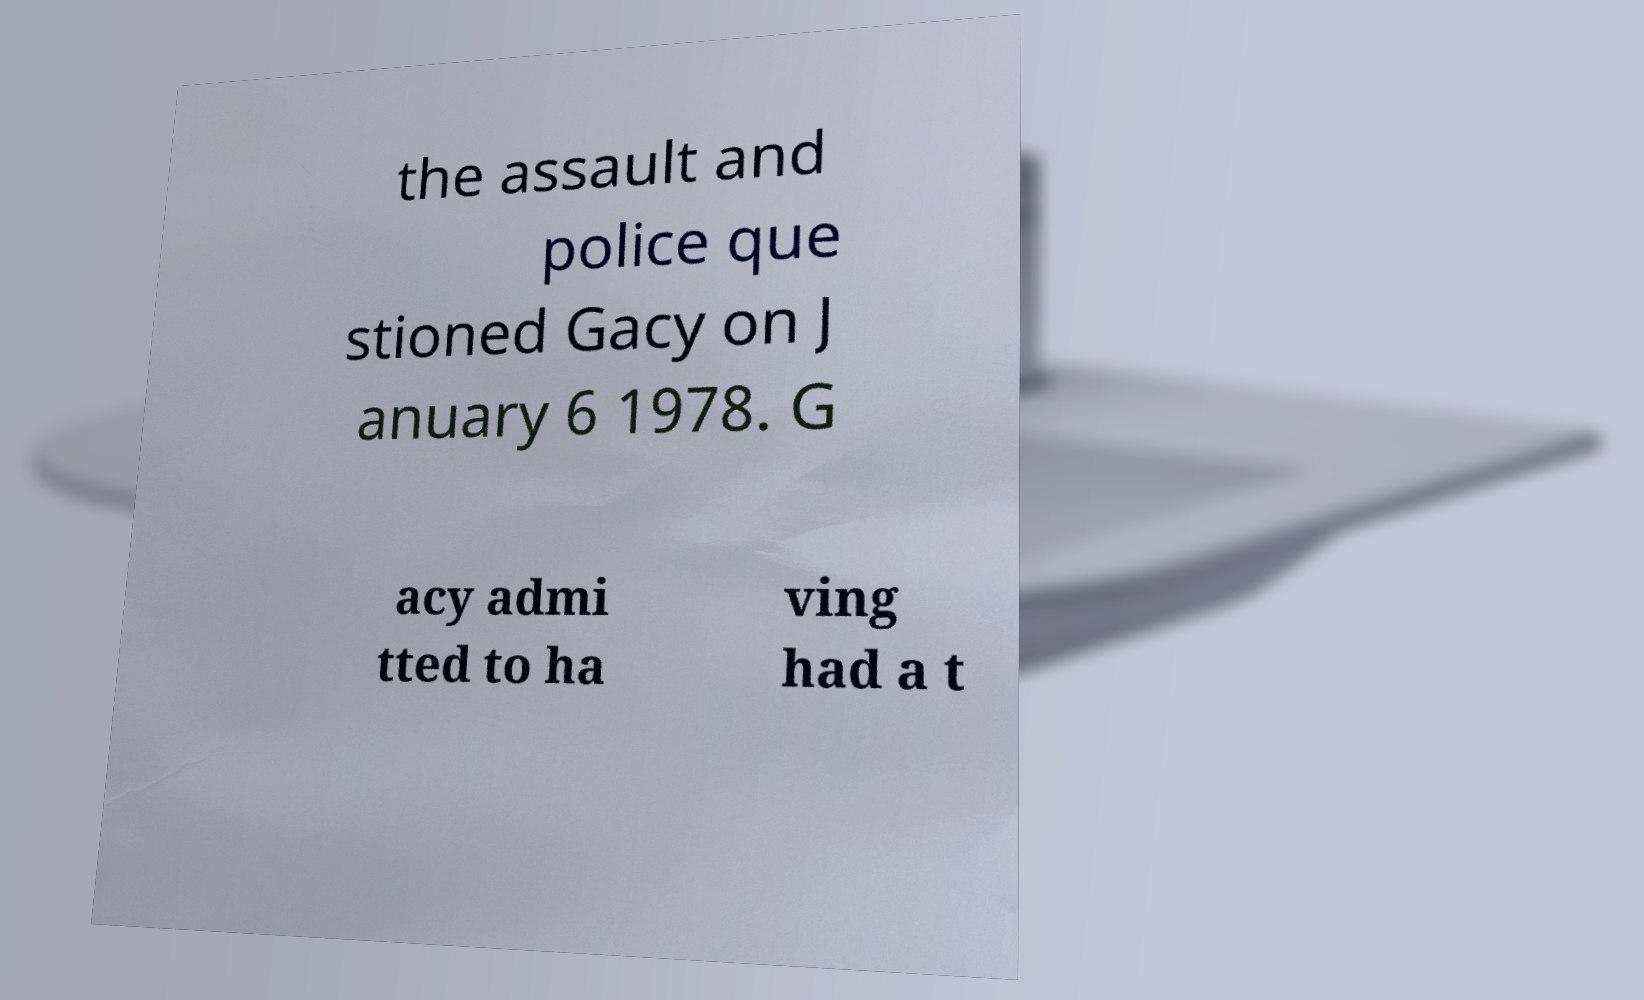Can you read and provide the text displayed in the image?This photo seems to have some interesting text. Can you extract and type it out for me? the assault and police que stioned Gacy on J anuary 6 1978. G acy admi tted to ha ving had a t 